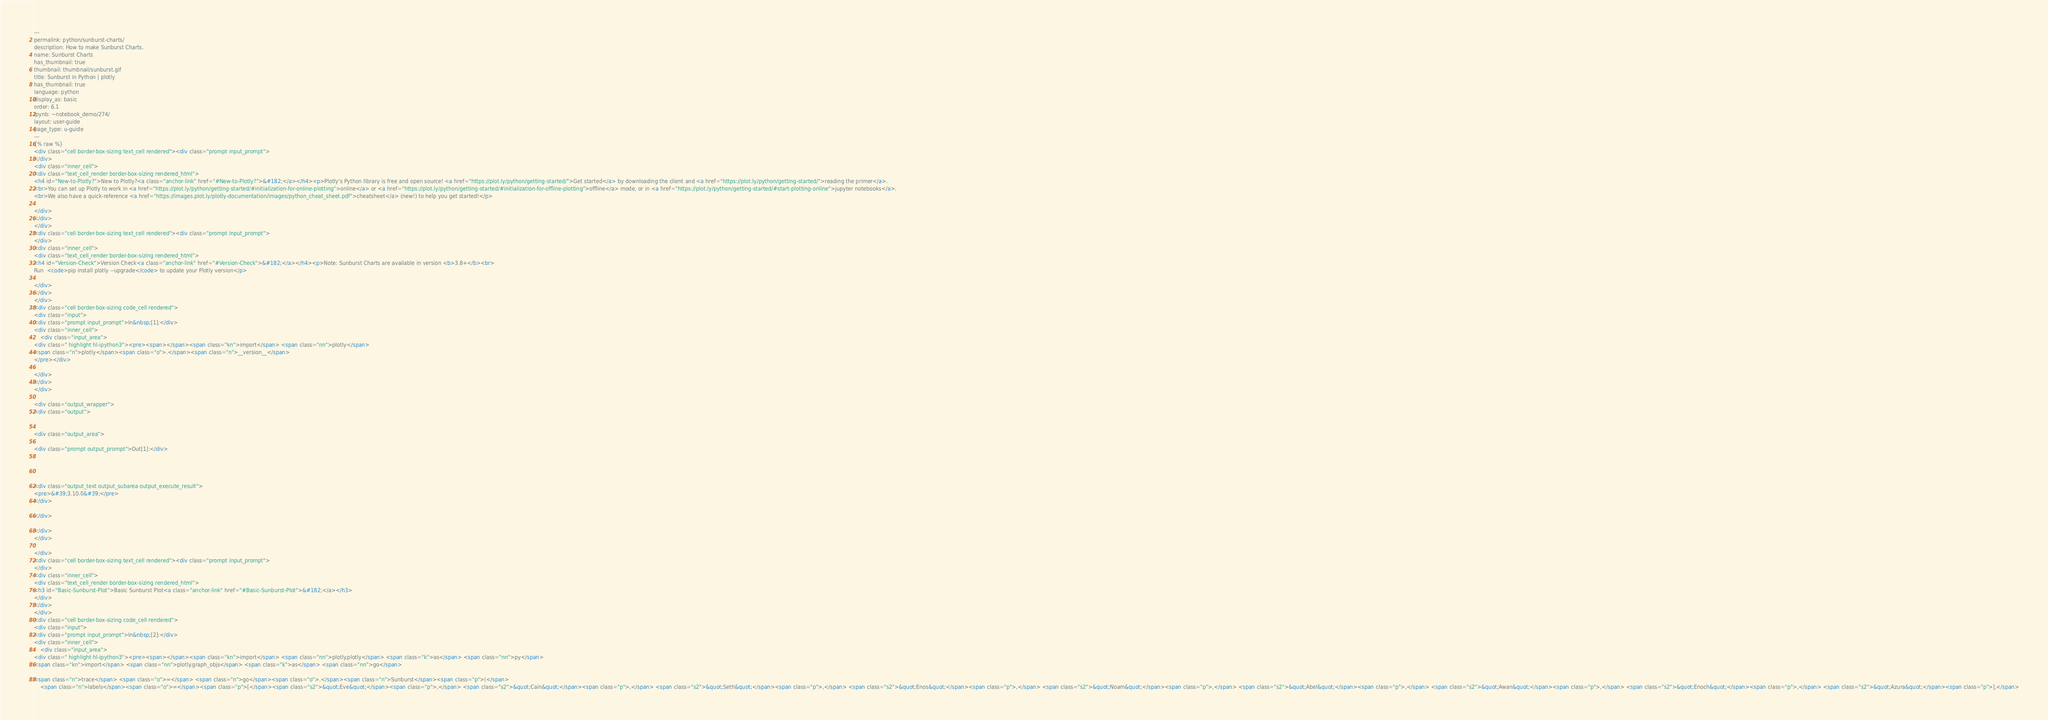<code> <loc_0><loc_0><loc_500><loc_500><_HTML_>---
permalink: python/sunburst-charts/
description: How to make Sunburst Charts.
name: Sunburst Charts
has_thumbnail: true
thumbnail: thumbnail/sunburst.gif
title: Sunburst in Python | plotly
has_thumbnail: true
language: python
display_as: basic
order: 6.1
ipynb: ~notebook_demo/274/
layout: user-guide
page_type: u-guide
---
{% raw %}
<div class="cell border-box-sizing text_cell rendered"><div class="prompt input_prompt">
</div>
<div class="inner_cell">
<div class="text_cell_render border-box-sizing rendered_html">
<h4 id="New-to-Plotly?">New to Plotly?<a class="anchor-link" href="#New-to-Plotly?">&#182;</a></h4><p>Plotly's Python library is free and open source! <a href="https://plot.ly/python/getting-started/">Get started</a> by downloading the client and <a href="https://plot.ly/python/getting-started/">reading the primer</a>.
<br>You can set up Plotly to work in <a href="https://plot.ly/python/getting-started/#initialization-for-online-plotting">online</a> or <a href="https://plot.ly/python/getting-started/#initialization-for-offline-plotting">offline</a> mode, or in <a href="https://plot.ly/python/getting-started/#start-plotting-online">jupyter notebooks</a>.
<br>We also have a quick-reference <a href="https://images.plot.ly/plotly-documentation/images/python_cheat_sheet.pdf">cheatsheet</a> (new!) to help you get started!</p>

</div>
</div>
</div>
<div class="cell border-box-sizing text_cell rendered"><div class="prompt input_prompt">
</div>
<div class="inner_cell">
<div class="text_cell_render border-box-sizing rendered_html">
<h4 id="Version-Check">Version Check<a class="anchor-link" href="#Version-Check">&#182;</a></h4><p>Note: Sunburst Charts are available in version <b>3.8+</b><br>
Run  <code>pip install plotly --upgrade</code> to update your Plotly version</p>

</div>
</div>
</div>
<div class="cell border-box-sizing code_cell rendered">
<div class="input">
<div class="prompt input_prompt">In&nbsp;[1]:</div>
<div class="inner_cell">
    <div class="input_area">
<div class=" highlight hl-ipython3"><pre><span></span><span class="kn">import</span> <span class="nn">plotly</span>
<span class="n">plotly</span><span class="o">.</span><span class="n">__version__</span>
</pre></div>

</div>
</div>
</div>

<div class="output_wrapper">
<div class="output">


<div class="output_area">

<div class="prompt output_prompt">Out[1]:</div>




<div class="output_text output_subarea output_execute_result">
<pre>&#39;3.10.0&#39;</pre>
</div>

</div>

</div>
</div>

</div>
<div class="cell border-box-sizing text_cell rendered"><div class="prompt input_prompt">
</div>
<div class="inner_cell">
<div class="text_cell_render border-box-sizing rendered_html">
<h3 id="Basic-Sunburst-Plot">Basic Sunburst Plot<a class="anchor-link" href="#Basic-Sunburst-Plot">&#182;</a></h3>
</div>
</div>
</div>
<div class="cell border-box-sizing code_cell rendered">
<div class="input">
<div class="prompt input_prompt">In&nbsp;[2]:</div>
<div class="inner_cell">
    <div class="input_area">
<div class=" highlight hl-ipython3"><pre><span></span><span class="kn">import</span> <span class="nn">plotly.plotly</span> <span class="k">as</span> <span class="nn">py</span>
<span class="kn">import</span> <span class="nn">plotly.graph_objs</span> <span class="k">as</span> <span class="nn">go</span>

<span class="n">trace</span> <span class="o">=</span> <span class="n">go</span><span class="o">.</span><span class="n">Sunburst</span><span class="p">(</span>
    <span class="n">labels</span><span class="o">=</span><span class="p">[</span><span class="s2">&quot;Eve&quot;</span><span class="p">,</span> <span class="s2">&quot;Cain&quot;</span><span class="p">,</span> <span class="s2">&quot;Seth&quot;</span><span class="p">,</span> <span class="s2">&quot;Enos&quot;</span><span class="p">,</span> <span class="s2">&quot;Noam&quot;</span><span class="p">,</span> <span class="s2">&quot;Abel&quot;</span><span class="p">,</span> <span class="s2">&quot;Awan&quot;</span><span class="p">,</span> <span class="s2">&quot;Enoch&quot;</span><span class="p">,</span> <span class="s2">&quot;Azura&quot;</span><span class="p">],</span></code> 